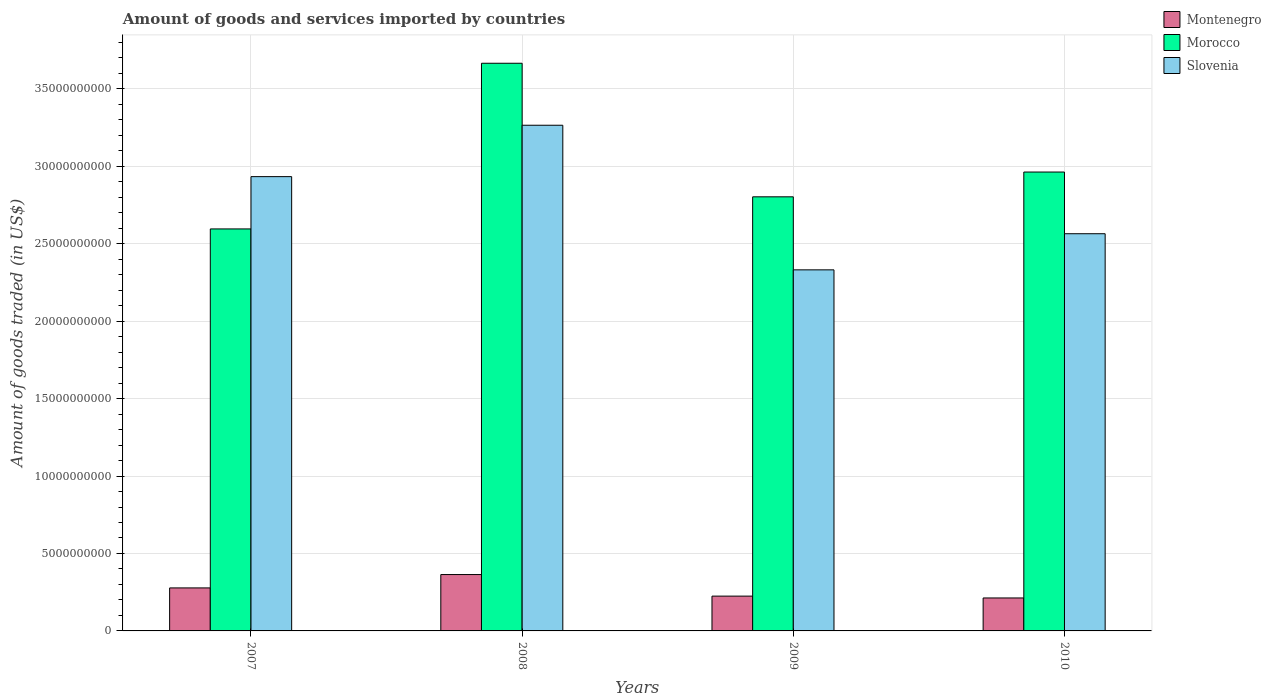How many different coloured bars are there?
Provide a short and direct response. 3. Are the number of bars per tick equal to the number of legend labels?
Keep it short and to the point. Yes. How many bars are there on the 4th tick from the left?
Keep it short and to the point. 3. How many bars are there on the 4th tick from the right?
Provide a short and direct response. 3. What is the total amount of goods and services imported in Slovenia in 2009?
Offer a terse response. 2.33e+1. Across all years, what is the maximum total amount of goods and services imported in Slovenia?
Provide a succinct answer. 3.26e+1. Across all years, what is the minimum total amount of goods and services imported in Morocco?
Your response must be concise. 2.60e+1. In which year was the total amount of goods and services imported in Montenegro maximum?
Your answer should be very brief. 2008. In which year was the total amount of goods and services imported in Slovenia minimum?
Make the answer very short. 2009. What is the total total amount of goods and services imported in Montenegro in the graph?
Provide a short and direct response. 1.08e+1. What is the difference between the total amount of goods and services imported in Slovenia in 2007 and that in 2009?
Provide a short and direct response. 6.02e+09. What is the difference between the total amount of goods and services imported in Montenegro in 2008 and the total amount of goods and services imported in Morocco in 2007?
Give a very brief answer. -2.23e+1. What is the average total amount of goods and services imported in Slovenia per year?
Give a very brief answer. 2.77e+1. In the year 2007, what is the difference between the total amount of goods and services imported in Morocco and total amount of goods and services imported in Slovenia?
Make the answer very short. -3.38e+09. What is the ratio of the total amount of goods and services imported in Montenegro in 2008 to that in 2010?
Keep it short and to the point. 1.71. Is the total amount of goods and services imported in Slovenia in 2008 less than that in 2010?
Provide a short and direct response. No. Is the difference between the total amount of goods and services imported in Morocco in 2008 and 2009 greater than the difference between the total amount of goods and services imported in Slovenia in 2008 and 2009?
Provide a succinct answer. No. What is the difference between the highest and the second highest total amount of goods and services imported in Montenegro?
Give a very brief answer. 8.63e+08. What is the difference between the highest and the lowest total amount of goods and services imported in Morocco?
Your response must be concise. 1.07e+1. Is the sum of the total amount of goods and services imported in Morocco in 2007 and 2009 greater than the maximum total amount of goods and services imported in Montenegro across all years?
Your response must be concise. Yes. What does the 1st bar from the left in 2008 represents?
Provide a succinct answer. Montenegro. What does the 2nd bar from the right in 2009 represents?
Offer a very short reply. Morocco. Is it the case that in every year, the sum of the total amount of goods and services imported in Slovenia and total amount of goods and services imported in Montenegro is greater than the total amount of goods and services imported in Morocco?
Ensure brevity in your answer.  No. How many years are there in the graph?
Your response must be concise. 4. Are the values on the major ticks of Y-axis written in scientific E-notation?
Keep it short and to the point. No. Where does the legend appear in the graph?
Offer a very short reply. Top right. How many legend labels are there?
Give a very brief answer. 3. What is the title of the graph?
Offer a terse response. Amount of goods and services imported by countries. What is the label or title of the X-axis?
Provide a short and direct response. Years. What is the label or title of the Y-axis?
Offer a terse response. Amount of goods traded (in US$). What is the Amount of goods traded (in US$) in Montenegro in 2007?
Offer a very short reply. 2.78e+09. What is the Amount of goods traded (in US$) in Morocco in 2007?
Make the answer very short. 2.60e+1. What is the Amount of goods traded (in US$) of Slovenia in 2007?
Provide a succinct answer. 2.93e+1. What is the Amount of goods traded (in US$) of Montenegro in 2008?
Offer a terse response. 3.64e+09. What is the Amount of goods traded (in US$) in Morocco in 2008?
Your answer should be very brief. 3.67e+1. What is the Amount of goods traded (in US$) in Slovenia in 2008?
Your answer should be compact. 3.26e+1. What is the Amount of goods traded (in US$) of Montenegro in 2009?
Keep it short and to the point. 2.25e+09. What is the Amount of goods traded (in US$) of Morocco in 2009?
Your answer should be compact. 2.80e+1. What is the Amount of goods traded (in US$) of Slovenia in 2009?
Offer a very short reply. 2.33e+1. What is the Amount of goods traded (in US$) in Montenegro in 2010?
Offer a terse response. 2.13e+09. What is the Amount of goods traded (in US$) in Morocco in 2010?
Make the answer very short. 2.96e+1. What is the Amount of goods traded (in US$) in Slovenia in 2010?
Provide a succinct answer. 2.56e+1. Across all years, what is the maximum Amount of goods traded (in US$) of Montenegro?
Provide a short and direct response. 3.64e+09. Across all years, what is the maximum Amount of goods traded (in US$) in Morocco?
Your answer should be compact. 3.67e+1. Across all years, what is the maximum Amount of goods traded (in US$) in Slovenia?
Keep it short and to the point. 3.26e+1. Across all years, what is the minimum Amount of goods traded (in US$) of Montenegro?
Your answer should be compact. 2.13e+09. Across all years, what is the minimum Amount of goods traded (in US$) of Morocco?
Offer a terse response. 2.60e+1. Across all years, what is the minimum Amount of goods traded (in US$) of Slovenia?
Your answer should be very brief. 2.33e+1. What is the total Amount of goods traded (in US$) of Montenegro in the graph?
Provide a succinct answer. 1.08e+1. What is the total Amount of goods traded (in US$) in Morocco in the graph?
Ensure brevity in your answer.  1.20e+11. What is the total Amount of goods traded (in US$) in Slovenia in the graph?
Give a very brief answer. 1.11e+11. What is the difference between the Amount of goods traded (in US$) in Montenegro in 2007 and that in 2008?
Offer a terse response. -8.63e+08. What is the difference between the Amount of goods traded (in US$) of Morocco in 2007 and that in 2008?
Give a very brief answer. -1.07e+1. What is the difference between the Amount of goods traded (in US$) of Slovenia in 2007 and that in 2008?
Your answer should be compact. -3.32e+09. What is the difference between the Amount of goods traded (in US$) in Montenegro in 2007 and that in 2009?
Provide a short and direct response. 5.30e+08. What is the difference between the Amount of goods traded (in US$) in Morocco in 2007 and that in 2009?
Your response must be concise. -2.07e+09. What is the difference between the Amount of goods traded (in US$) in Slovenia in 2007 and that in 2009?
Provide a short and direct response. 6.02e+09. What is the difference between the Amount of goods traded (in US$) in Montenegro in 2007 and that in 2010?
Provide a short and direct response. 6.48e+08. What is the difference between the Amount of goods traded (in US$) in Morocco in 2007 and that in 2010?
Offer a very short reply. -3.67e+09. What is the difference between the Amount of goods traded (in US$) in Slovenia in 2007 and that in 2010?
Give a very brief answer. 3.69e+09. What is the difference between the Amount of goods traded (in US$) of Montenegro in 2008 and that in 2009?
Ensure brevity in your answer.  1.39e+09. What is the difference between the Amount of goods traded (in US$) in Morocco in 2008 and that in 2009?
Offer a terse response. 8.62e+09. What is the difference between the Amount of goods traded (in US$) of Slovenia in 2008 and that in 2009?
Keep it short and to the point. 9.34e+09. What is the difference between the Amount of goods traded (in US$) in Montenegro in 2008 and that in 2010?
Offer a very short reply. 1.51e+09. What is the difference between the Amount of goods traded (in US$) of Morocco in 2008 and that in 2010?
Your answer should be compact. 7.02e+09. What is the difference between the Amount of goods traded (in US$) of Slovenia in 2008 and that in 2010?
Offer a terse response. 7.00e+09. What is the difference between the Amount of goods traded (in US$) in Montenegro in 2009 and that in 2010?
Your response must be concise. 1.18e+08. What is the difference between the Amount of goods traded (in US$) of Morocco in 2009 and that in 2010?
Make the answer very short. -1.60e+09. What is the difference between the Amount of goods traded (in US$) in Slovenia in 2009 and that in 2010?
Your answer should be compact. -2.33e+09. What is the difference between the Amount of goods traded (in US$) in Montenegro in 2007 and the Amount of goods traded (in US$) in Morocco in 2008?
Provide a short and direct response. -3.39e+1. What is the difference between the Amount of goods traded (in US$) of Montenegro in 2007 and the Amount of goods traded (in US$) of Slovenia in 2008?
Make the answer very short. -2.99e+1. What is the difference between the Amount of goods traded (in US$) in Morocco in 2007 and the Amount of goods traded (in US$) in Slovenia in 2008?
Ensure brevity in your answer.  -6.70e+09. What is the difference between the Amount of goods traded (in US$) in Montenegro in 2007 and the Amount of goods traded (in US$) in Morocco in 2009?
Offer a terse response. -2.53e+1. What is the difference between the Amount of goods traded (in US$) of Montenegro in 2007 and the Amount of goods traded (in US$) of Slovenia in 2009?
Make the answer very short. -2.05e+1. What is the difference between the Amount of goods traded (in US$) of Morocco in 2007 and the Amount of goods traded (in US$) of Slovenia in 2009?
Offer a terse response. 2.64e+09. What is the difference between the Amount of goods traded (in US$) of Montenegro in 2007 and the Amount of goods traded (in US$) of Morocco in 2010?
Provide a succinct answer. -2.69e+1. What is the difference between the Amount of goods traded (in US$) in Montenegro in 2007 and the Amount of goods traded (in US$) in Slovenia in 2010?
Ensure brevity in your answer.  -2.29e+1. What is the difference between the Amount of goods traded (in US$) in Morocco in 2007 and the Amount of goods traded (in US$) in Slovenia in 2010?
Offer a very short reply. 3.10e+08. What is the difference between the Amount of goods traded (in US$) of Montenegro in 2008 and the Amount of goods traded (in US$) of Morocco in 2009?
Give a very brief answer. -2.44e+1. What is the difference between the Amount of goods traded (in US$) in Montenegro in 2008 and the Amount of goods traded (in US$) in Slovenia in 2009?
Offer a very short reply. -1.97e+1. What is the difference between the Amount of goods traded (in US$) of Morocco in 2008 and the Amount of goods traded (in US$) of Slovenia in 2009?
Provide a succinct answer. 1.33e+1. What is the difference between the Amount of goods traded (in US$) in Montenegro in 2008 and the Amount of goods traded (in US$) in Morocco in 2010?
Your answer should be compact. -2.60e+1. What is the difference between the Amount of goods traded (in US$) of Montenegro in 2008 and the Amount of goods traded (in US$) of Slovenia in 2010?
Offer a terse response. -2.20e+1. What is the difference between the Amount of goods traded (in US$) of Morocco in 2008 and the Amount of goods traded (in US$) of Slovenia in 2010?
Offer a very short reply. 1.10e+1. What is the difference between the Amount of goods traded (in US$) in Montenegro in 2009 and the Amount of goods traded (in US$) in Morocco in 2010?
Make the answer very short. -2.74e+1. What is the difference between the Amount of goods traded (in US$) of Montenegro in 2009 and the Amount of goods traded (in US$) of Slovenia in 2010?
Your answer should be very brief. -2.34e+1. What is the difference between the Amount of goods traded (in US$) of Morocco in 2009 and the Amount of goods traded (in US$) of Slovenia in 2010?
Provide a succinct answer. 2.38e+09. What is the average Amount of goods traded (in US$) of Montenegro per year?
Provide a short and direct response. 2.70e+09. What is the average Amount of goods traded (in US$) of Morocco per year?
Offer a terse response. 3.01e+1. What is the average Amount of goods traded (in US$) in Slovenia per year?
Make the answer very short. 2.77e+1. In the year 2007, what is the difference between the Amount of goods traded (in US$) in Montenegro and Amount of goods traded (in US$) in Morocco?
Your answer should be compact. -2.32e+1. In the year 2007, what is the difference between the Amount of goods traded (in US$) of Montenegro and Amount of goods traded (in US$) of Slovenia?
Provide a succinct answer. -2.66e+1. In the year 2007, what is the difference between the Amount of goods traded (in US$) of Morocco and Amount of goods traded (in US$) of Slovenia?
Make the answer very short. -3.38e+09. In the year 2008, what is the difference between the Amount of goods traded (in US$) of Montenegro and Amount of goods traded (in US$) of Morocco?
Make the answer very short. -3.30e+1. In the year 2008, what is the difference between the Amount of goods traded (in US$) in Montenegro and Amount of goods traded (in US$) in Slovenia?
Provide a succinct answer. -2.90e+1. In the year 2008, what is the difference between the Amount of goods traded (in US$) in Morocco and Amount of goods traded (in US$) in Slovenia?
Ensure brevity in your answer.  4.00e+09. In the year 2009, what is the difference between the Amount of goods traded (in US$) of Montenegro and Amount of goods traded (in US$) of Morocco?
Give a very brief answer. -2.58e+1. In the year 2009, what is the difference between the Amount of goods traded (in US$) in Montenegro and Amount of goods traded (in US$) in Slovenia?
Offer a very short reply. -2.11e+1. In the year 2009, what is the difference between the Amount of goods traded (in US$) in Morocco and Amount of goods traded (in US$) in Slovenia?
Offer a very short reply. 4.72e+09. In the year 2010, what is the difference between the Amount of goods traded (in US$) in Montenegro and Amount of goods traded (in US$) in Morocco?
Your response must be concise. -2.75e+1. In the year 2010, what is the difference between the Amount of goods traded (in US$) of Montenegro and Amount of goods traded (in US$) of Slovenia?
Offer a terse response. -2.35e+1. In the year 2010, what is the difference between the Amount of goods traded (in US$) in Morocco and Amount of goods traded (in US$) in Slovenia?
Provide a succinct answer. 3.98e+09. What is the ratio of the Amount of goods traded (in US$) in Montenegro in 2007 to that in 2008?
Make the answer very short. 0.76. What is the ratio of the Amount of goods traded (in US$) in Morocco in 2007 to that in 2008?
Offer a very short reply. 0.71. What is the ratio of the Amount of goods traded (in US$) of Slovenia in 2007 to that in 2008?
Keep it short and to the point. 0.9. What is the ratio of the Amount of goods traded (in US$) in Montenegro in 2007 to that in 2009?
Offer a terse response. 1.24. What is the ratio of the Amount of goods traded (in US$) of Morocco in 2007 to that in 2009?
Make the answer very short. 0.93. What is the ratio of the Amount of goods traded (in US$) of Slovenia in 2007 to that in 2009?
Give a very brief answer. 1.26. What is the ratio of the Amount of goods traded (in US$) in Montenegro in 2007 to that in 2010?
Provide a short and direct response. 1.3. What is the ratio of the Amount of goods traded (in US$) of Morocco in 2007 to that in 2010?
Keep it short and to the point. 0.88. What is the ratio of the Amount of goods traded (in US$) in Slovenia in 2007 to that in 2010?
Offer a very short reply. 1.14. What is the ratio of the Amount of goods traded (in US$) in Montenegro in 2008 to that in 2009?
Keep it short and to the point. 1.62. What is the ratio of the Amount of goods traded (in US$) in Morocco in 2008 to that in 2009?
Ensure brevity in your answer.  1.31. What is the ratio of the Amount of goods traded (in US$) in Slovenia in 2008 to that in 2009?
Make the answer very short. 1.4. What is the ratio of the Amount of goods traded (in US$) of Montenegro in 2008 to that in 2010?
Your response must be concise. 1.71. What is the ratio of the Amount of goods traded (in US$) of Morocco in 2008 to that in 2010?
Your answer should be very brief. 1.24. What is the ratio of the Amount of goods traded (in US$) of Slovenia in 2008 to that in 2010?
Your answer should be very brief. 1.27. What is the ratio of the Amount of goods traded (in US$) of Montenegro in 2009 to that in 2010?
Ensure brevity in your answer.  1.06. What is the ratio of the Amount of goods traded (in US$) in Morocco in 2009 to that in 2010?
Offer a very short reply. 0.95. What is the ratio of the Amount of goods traded (in US$) of Slovenia in 2009 to that in 2010?
Your answer should be compact. 0.91. What is the difference between the highest and the second highest Amount of goods traded (in US$) in Montenegro?
Your answer should be very brief. 8.63e+08. What is the difference between the highest and the second highest Amount of goods traded (in US$) in Morocco?
Provide a succinct answer. 7.02e+09. What is the difference between the highest and the second highest Amount of goods traded (in US$) in Slovenia?
Offer a very short reply. 3.32e+09. What is the difference between the highest and the lowest Amount of goods traded (in US$) in Montenegro?
Your response must be concise. 1.51e+09. What is the difference between the highest and the lowest Amount of goods traded (in US$) of Morocco?
Ensure brevity in your answer.  1.07e+1. What is the difference between the highest and the lowest Amount of goods traded (in US$) of Slovenia?
Your response must be concise. 9.34e+09. 